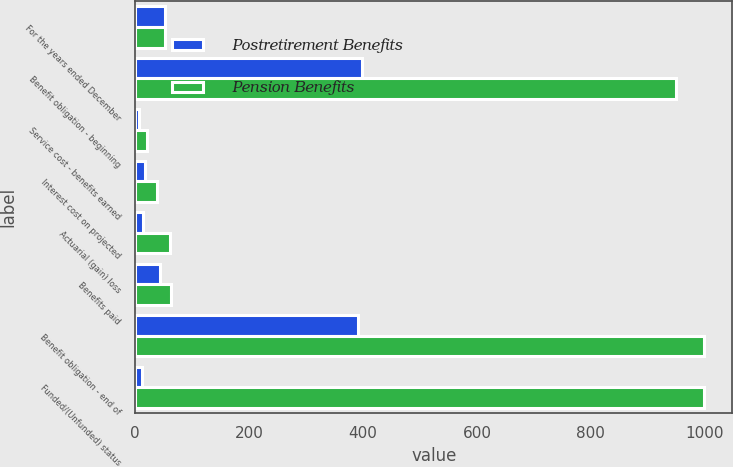Convert chart. <chart><loc_0><loc_0><loc_500><loc_500><stacked_bar_chart><ecel><fcel>For the years ended December<fcel>Benefit obligation - beginning<fcel>Service cost - benefits earned<fcel>Interest cost on projected<fcel>Actuarial (gain) loss<fcel>Benefits paid<fcel>Benefit obligation - end of<fcel>Funded/(Unfunded) status<nl><fcel>Postretirement Benefits<fcel>52.5<fcel>399<fcel>6<fcel>17<fcel>14<fcel>44<fcel>391<fcel>12<nl><fcel>Pension Benefits<fcel>52.5<fcel>950<fcel>21<fcel>38<fcel>61<fcel>62<fcel>999<fcel>999<nl></chart> 